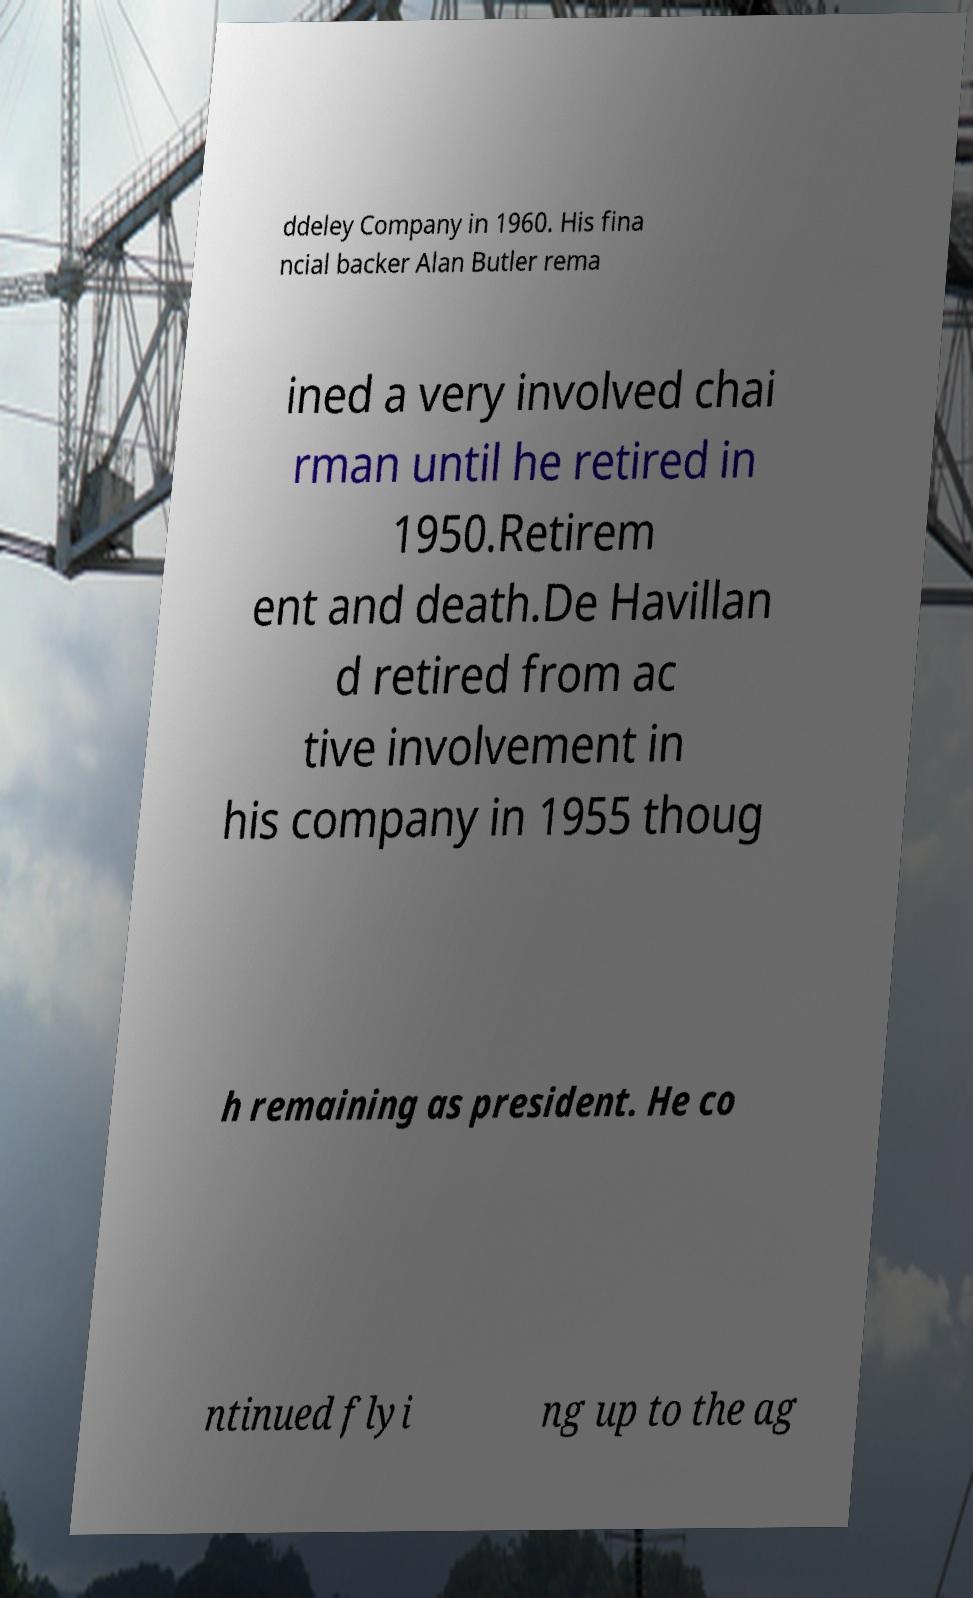Could you extract and type out the text from this image? ddeley Company in 1960. His fina ncial backer Alan Butler rema ined a very involved chai rman until he retired in 1950.Retirem ent and death.De Havillan d retired from ac tive involvement in his company in 1955 thoug h remaining as president. He co ntinued flyi ng up to the ag 